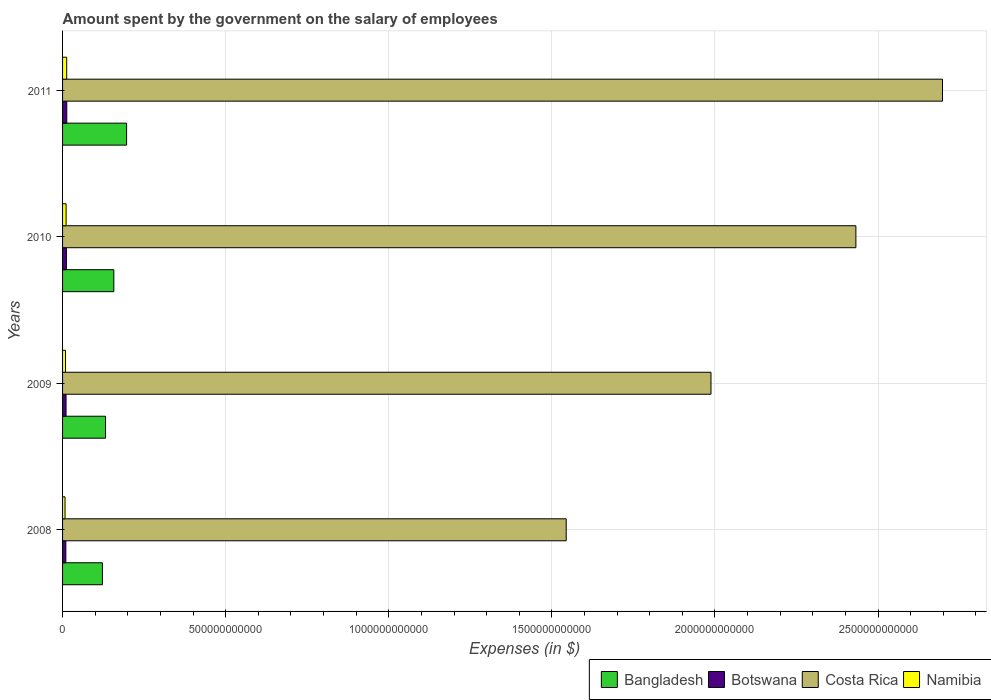How many groups of bars are there?
Your answer should be very brief. 4. In how many cases, is the number of bars for a given year not equal to the number of legend labels?
Provide a short and direct response. 0. What is the amount spent on the salary of employees by the government in Bangladesh in 2008?
Keep it short and to the point. 1.22e+11. Across all years, what is the maximum amount spent on the salary of employees by the government in Namibia?
Your answer should be very brief. 1.27e+1. Across all years, what is the minimum amount spent on the salary of employees by the government in Costa Rica?
Ensure brevity in your answer.  1.54e+12. In which year was the amount spent on the salary of employees by the government in Bangladesh maximum?
Your answer should be compact. 2011. In which year was the amount spent on the salary of employees by the government in Costa Rica minimum?
Keep it short and to the point. 2008. What is the total amount spent on the salary of employees by the government in Botswana in the graph?
Ensure brevity in your answer.  4.56e+1. What is the difference between the amount spent on the salary of employees by the government in Namibia in 2010 and that in 2011?
Your answer should be very brief. -1.89e+09. What is the difference between the amount spent on the salary of employees by the government in Botswana in 2010 and the amount spent on the salary of employees by the government in Costa Rica in 2008?
Offer a terse response. -1.53e+12. What is the average amount spent on the salary of employees by the government in Namibia per year?
Give a very brief answer. 1.00e+1. In the year 2009, what is the difference between the amount spent on the salary of employees by the government in Namibia and amount spent on the salary of employees by the government in Botswana?
Ensure brevity in your answer.  -1.64e+09. What is the ratio of the amount spent on the salary of employees by the government in Bangladesh in 2008 to that in 2011?
Keep it short and to the point. 0.62. Is the amount spent on the salary of employees by the government in Bangladesh in 2009 less than that in 2011?
Your answer should be very brief. Yes. What is the difference between the highest and the second highest amount spent on the salary of employees by the government in Namibia?
Offer a very short reply. 1.89e+09. What is the difference between the highest and the lowest amount spent on the salary of employees by the government in Namibia?
Ensure brevity in your answer.  5.13e+09. Is the sum of the amount spent on the salary of employees by the government in Bangladesh in 2008 and 2010 greater than the maximum amount spent on the salary of employees by the government in Costa Rica across all years?
Give a very brief answer. No. Is it the case that in every year, the sum of the amount spent on the salary of employees by the government in Botswana and amount spent on the salary of employees by the government in Namibia is greater than the sum of amount spent on the salary of employees by the government in Costa Rica and amount spent on the salary of employees by the government in Bangladesh?
Make the answer very short. No. What does the 1st bar from the top in 2008 represents?
Ensure brevity in your answer.  Namibia. Is it the case that in every year, the sum of the amount spent on the salary of employees by the government in Costa Rica and amount spent on the salary of employees by the government in Namibia is greater than the amount spent on the salary of employees by the government in Bangladesh?
Offer a very short reply. Yes. How many bars are there?
Give a very brief answer. 16. How many years are there in the graph?
Make the answer very short. 4. What is the difference between two consecutive major ticks on the X-axis?
Provide a succinct answer. 5.00e+11. Does the graph contain any zero values?
Offer a very short reply. No. Does the graph contain grids?
Your answer should be compact. Yes. How many legend labels are there?
Offer a terse response. 4. What is the title of the graph?
Your answer should be very brief. Amount spent by the government on the salary of employees. What is the label or title of the X-axis?
Give a very brief answer. Expenses (in $). What is the label or title of the Y-axis?
Ensure brevity in your answer.  Years. What is the Expenses (in $) of Bangladesh in 2008?
Offer a terse response. 1.22e+11. What is the Expenses (in $) in Botswana in 2008?
Offer a very short reply. 1.01e+1. What is the Expenses (in $) of Costa Rica in 2008?
Make the answer very short. 1.54e+12. What is the Expenses (in $) of Namibia in 2008?
Your answer should be very brief. 7.56e+09. What is the Expenses (in $) in Bangladesh in 2009?
Make the answer very short. 1.32e+11. What is the Expenses (in $) in Botswana in 2009?
Make the answer very short. 1.07e+1. What is the Expenses (in $) of Costa Rica in 2009?
Provide a short and direct response. 1.99e+12. What is the Expenses (in $) of Namibia in 2009?
Your answer should be very brief. 9.05e+09. What is the Expenses (in $) of Bangladesh in 2010?
Your response must be concise. 1.57e+11. What is the Expenses (in $) in Botswana in 2010?
Provide a short and direct response. 1.19e+1. What is the Expenses (in $) of Costa Rica in 2010?
Your response must be concise. 2.43e+12. What is the Expenses (in $) of Namibia in 2010?
Give a very brief answer. 1.08e+1. What is the Expenses (in $) of Bangladesh in 2011?
Give a very brief answer. 1.96e+11. What is the Expenses (in $) of Botswana in 2011?
Keep it short and to the point. 1.29e+1. What is the Expenses (in $) of Costa Rica in 2011?
Make the answer very short. 2.70e+12. What is the Expenses (in $) of Namibia in 2011?
Give a very brief answer. 1.27e+1. Across all years, what is the maximum Expenses (in $) of Bangladesh?
Ensure brevity in your answer.  1.96e+11. Across all years, what is the maximum Expenses (in $) in Botswana?
Give a very brief answer. 1.29e+1. Across all years, what is the maximum Expenses (in $) in Costa Rica?
Your answer should be compact. 2.70e+12. Across all years, what is the maximum Expenses (in $) of Namibia?
Provide a short and direct response. 1.27e+1. Across all years, what is the minimum Expenses (in $) of Bangladesh?
Give a very brief answer. 1.22e+11. Across all years, what is the minimum Expenses (in $) of Botswana?
Provide a short and direct response. 1.01e+1. Across all years, what is the minimum Expenses (in $) in Costa Rica?
Ensure brevity in your answer.  1.54e+12. Across all years, what is the minimum Expenses (in $) in Namibia?
Keep it short and to the point. 7.56e+09. What is the total Expenses (in $) of Bangladesh in the graph?
Provide a succinct answer. 6.07e+11. What is the total Expenses (in $) of Botswana in the graph?
Your answer should be very brief. 4.56e+1. What is the total Expenses (in $) of Costa Rica in the graph?
Your answer should be very brief. 8.66e+12. What is the total Expenses (in $) in Namibia in the graph?
Keep it short and to the point. 4.01e+1. What is the difference between the Expenses (in $) in Bangladesh in 2008 and that in 2009?
Make the answer very short. -9.53e+09. What is the difference between the Expenses (in $) in Botswana in 2008 and that in 2009?
Offer a very short reply. -6.17e+08. What is the difference between the Expenses (in $) in Costa Rica in 2008 and that in 2009?
Offer a very short reply. -4.44e+11. What is the difference between the Expenses (in $) of Namibia in 2008 and that in 2009?
Your response must be concise. -1.49e+09. What is the difference between the Expenses (in $) in Bangladesh in 2008 and that in 2010?
Provide a succinct answer. -3.50e+1. What is the difference between the Expenses (in $) of Botswana in 2008 and that in 2010?
Provide a short and direct response. -1.83e+09. What is the difference between the Expenses (in $) in Costa Rica in 2008 and that in 2010?
Your response must be concise. -8.88e+11. What is the difference between the Expenses (in $) of Namibia in 2008 and that in 2010?
Make the answer very short. -3.24e+09. What is the difference between the Expenses (in $) in Bangladesh in 2008 and that in 2011?
Your response must be concise. -7.41e+1. What is the difference between the Expenses (in $) of Botswana in 2008 and that in 2011?
Your answer should be very brief. -2.87e+09. What is the difference between the Expenses (in $) in Costa Rica in 2008 and that in 2011?
Make the answer very short. -1.15e+12. What is the difference between the Expenses (in $) of Namibia in 2008 and that in 2011?
Your answer should be very brief. -5.13e+09. What is the difference between the Expenses (in $) in Bangladesh in 2009 and that in 2010?
Your response must be concise. -2.55e+1. What is the difference between the Expenses (in $) in Botswana in 2009 and that in 2010?
Offer a very short reply. -1.22e+09. What is the difference between the Expenses (in $) of Costa Rica in 2009 and that in 2010?
Make the answer very short. -4.44e+11. What is the difference between the Expenses (in $) of Namibia in 2009 and that in 2010?
Provide a succinct answer. -1.76e+09. What is the difference between the Expenses (in $) in Bangladesh in 2009 and that in 2011?
Provide a succinct answer. -6.46e+1. What is the difference between the Expenses (in $) in Botswana in 2009 and that in 2011?
Keep it short and to the point. -2.26e+09. What is the difference between the Expenses (in $) in Costa Rica in 2009 and that in 2011?
Make the answer very short. -7.10e+11. What is the difference between the Expenses (in $) of Namibia in 2009 and that in 2011?
Offer a very short reply. -3.64e+09. What is the difference between the Expenses (in $) of Bangladesh in 2010 and that in 2011?
Ensure brevity in your answer.  -3.91e+1. What is the difference between the Expenses (in $) in Botswana in 2010 and that in 2011?
Your answer should be compact. -1.04e+09. What is the difference between the Expenses (in $) of Costa Rica in 2010 and that in 2011?
Your answer should be very brief. -2.65e+11. What is the difference between the Expenses (in $) in Namibia in 2010 and that in 2011?
Offer a terse response. -1.89e+09. What is the difference between the Expenses (in $) of Bangladesh in 2008 and the Expenses (in $) of Botswana in 2009?
Provide a succinct answer. 1.11e+11. What is the difference between the Expenses (in $) of Bangladesh in 2008 and the Expenses (in $) of Costa Rica in 2009?
Offer a very short reply. -1.87e+12. What is the difference between the Expenses (in $) of Bangladesh in 2008 and the Expenses (in $) of Namibia in 2009?
Your answer should be compact. 1.13e+11. What is the difference between the Expenses (in $) in Botswana in 2008 and the Expenses (in $) in Costa Rica in 2009?
Your response must be concise. -1.98e+12. What is the difference between the Expenses (in $) in Botswana in 2008 and the Expenses (in $) in Namibia in 2009?
Your answer should be compact. 1.02e+09. What is the difference between the Expenses (in $) of Costa Rica in 2008 and the Expenses (in $) of Namibia in 2009?
Offer a very short reply. 1.53e+12. What is the difference between the Expenses (in $) in Bangladesh in 2008 and the Expenses (in $) in Botswana in 2010?
Ensure brevity in your answer.  1.10e+11. What is the difference between the Expenses (in $) of Bangladesh in 2008 and the Expenses (in $) of Costa Rica in 2010?
Your answer should be very brief. -2.31e+12. What is the difference between the Expenses (in $) of Bangladesh in 2008 and the Expenses (in $) of Namibia in 2010?
Keep it short and to the point. 1.11e+11. What is the difference between the Expenses (in $) in Botswana in 2008 and the Expenses (in $) in Costa Rica in 2010?
Ensure brevity in your answer.  -2.42e+12. What is the difference between the Expenses (in $) of Botswana in 2008 and the Expenses (in $) of Namibia in 2010?
Keep it short and to the point. -7.35e+08. What is the difference between the Expenses (in $) in Costa Rica in 2008 and the Expenses (in $) in Namibia in 2010?
Your response must be concise. 1.53e+12. What is the difference between the Expenses (in $) in Bangladesh in 2008 and the Expenses (in $) in Botswana in 2011?
Give a very brief answer. 1.09e+11. What is the difference between the Expenses (in $) of Bangladesh in 2008 and the Expenses (in $) of Costa Rica in 2011?
Offer a terse response. -2.58e+12. What is the difference between the Expenses (in $) of Bangladesh in 2008 and the Expenses (in $) of Namibia in 2011?
Your answer should be compact. 1.09e+11. What is the difference between the Expenses (in $) in Botswana in 2008 and the Expenses (in $) in Costa Rica in 2011?
Offer a terse response. -2.69e+12. What is the difference between the Expenses (in $) of Botswana in 2008 and the Expenses (in $) of Namibia in 2011?
Make the answer very short. -2.62e+09. What is the difference between the Expenses (in $) of Costa Rica in 2008 and the Expenses (in $) of Namibia in 2011?
Your answer should be very brief. 1.53e+12. What is the difference between the Expenses (in $) in Bangladesh in 2009 and the Expenses (in $) in Botswana in 2010?
Give a very brief answer. 1.20e+11. What is the difference between the Expenses (in $) in Bangladesh in 2009 and the Expenses (in $) in Costa Rica in 2010?
Your answer should be compact. -2.30e+12. What is the difference between the Expenses (in $) in Bangladesh in 2009 and the Expenses (in $) in Namibia in 2010?
Provide a succinct answer. 1.21e+11. What is the difference between the Expenses (in $) in Botswana in 2009 and the Expenses (in $) in Costa Rica in 2010?
Your answer should be compact. -2.42e+12. What is the difference between the Expenses (in $) of Botswana in 2009 and the Expenses (in $) of Namibia in 2010?
Your answer should be very brief. -1.19e+08. What is the difference between the Expenses (in $) of Costa Rica in 2009 and the Expenses (in $) of Namibia in 2010?
Your answer should be very brief. 1.98e+12. What is the difference between the Expenses (in $) of Bangladesh in 2009 and the Expenses (in $) of Botswana in 2011?
Keep it short and to the point. 1.19e+11. What is the difference between the Expenses (in $) of Bangladesh in 2009 and the Expenses (in $) of Costa Rica in 2011?
Make the answer very short. -2.57e+12. What is the difference between the Expenses (in $) in Bangladesh in 2009 and the Expenses (in $) in Namibia in 2011?
Offer a terse response. 1.19e+11. What is the difference between the Expenses (in $) of Botswana in 2009 and the Expenses (in $) of Costa Rica in 2011?
Provide a succinct answer. -2.69e+12. What is the difference between the Expenses (in $) of Botswana in 2009 and the Expenses (in $) of Namibia in 2011?
Ensure brevity in your answer.  -2.01e+09. What is the difference between the Expenses (in $) of Costa Rica in 2009 and the Expenses (in $) of Namibia in 2011?
Make the answer very short. 1.98e+12. What is the difference between the Expenses (in $) in Bangladesh in 2010 and the Expenses (in $) in Botswana in 2011?
Provide a short and direct response. 1.44e+11. What is the difference between the Expenses (in $) of Bangladesh in 2010 and the Expenses (in $) of Costa Rica in 2011?
Your response must be concise. -2.54e+12. What is the difference between the Expenses (in $) in Bangladesh in 2010 and the Expenses (in $) in Namibia in 2011?
Offer a very short reply. 1.44e+11. What is the difference between the Expenses (in $) of Botswana in 2010 and the Expenses (in $) of Costa Rica in 2011?
Your answer should be very brief. -2.69e+12. What is the difference between the Expenses (in $) of Botswana in 2010 and the Expenses (in $) of Namibia in 2011?
Keep it short and to the point. -7.91e+08. What is the difference between the Expenses (in $) in Costa Rica in 2010 and the Expenses (in $) in Namibia in 2011?
Your response must be concise. 2.42e+12. What is the average Expenses (in $) in Bangladesh per year?
Your response must be concise. 1.52e+11. What is the average Expenses (in $) of Botswana per year?
Give a very brief answer. 1.14e+1. What is the average Expenses (in $) of Costa Rica per year?
Ensure brevity in your answer.  2.17e+12. What is the average Expenses (in $) in Namibia per year?
Give a very brief answer. 1.00e+1. In the year 2008, what is the difference between the Expenses (in $) of Bangladesh and Expenses (in $) of Botswana?
Offer a very short reply. 1.12e+11. In the year 2008, what is the difference between the Expenses (in $) of Bangladesh and Expenses (in $) of Costa Rica?
Ensure brevity in your answer.  -1.42e+12. In the year 2008, what is the difference between the Expenses (in $) of Bangladesh and Expenses (in $) of Namibia?
Offer a terse response. 1.15e+11. In the year 2008, what is the difference between the Expenses (in $) of Botswana and Expenses (in $) of Costa Rica?
Ensure brevity in your answer.  -1.53e+12. In the year 2008, what is the difference between the Expenses (in $) of Botswana and Expenses (in $) of Namibia?
Your answer should be compact. 2.51e+09. In the year 2008, what is the difference between the Expenses (in $) of Costa Rica and Expenses (in $) of Namibia?
Provide a succinct answer. 1.54e+12. In the year 2009, what is the difference between the Expenses (in $) of Bangladesh and Expenses (in $) of Botswana?
Offer a very short reply. 1.21e+11. In the year 2009, what is the difference between the Expenses (in $) in Bangladesh and Expenses (in $) in Costa Rica?
Provide a succinct answer. -1.86e+12. In the year 2009, what is the difference between the Expenses (in $) in Bangladesh and Expenses (in $) in Namibia?
Your answer should be compact. 1.23e+11. In the year 2009, what is the difference between the Expenses (in $) in Botswana and Expenses (in $) in Costa Rica?
Give a very brief answer. -1.98e+12. In the year 2009, what is the difference between the Expenses (in $) in Botswana and Expenses (in $) in Namibia?
Provide a succinct answer. 1.64e+09. In the year 2009, what is the difference between the Expenses (in $) in Costa Rica and Expenses (in $) in Namibia?
Make the answer very short. 1.98e+12. In the year 2010, what is the difference between the Expenses (in $) in Bangladesh and Expenses (in $) in Botswana?
Offer a terse response. 1.45e+11. In the year 2010, what is the difference between the Expenses (in $) of Bangladesh and Expenses (in $) of Costa Rica?
Ensure brevity in your answer.  -2.27e+12. In the year 2010, what is the difference between the Expenses (in $) in Bangladesh and Expenses (in $) in Namibia?
Keep it short and to the point. 1.46e+11. In the year 2010, what is the difference between the Expenses (in $) of Botswana and Expenses (in $) of Costa Rica?
Ensure brevity in your answer.  -2.42e+12. In the year 2010, what is the difference between the Expenses (in $) of Botswana and Expenses (in $) of Namibia?
Provide a short and direct response. 1.10e+09. In the year 2010, what is the difference between the Expenses (in $) in Costa Rica and Expenses (in $) in Namibia?
Make the answer very short. 2.42e+12. In the year 2011, what is the difference between the Expenses (in $) in Bangladesh and Expenses (in $) in Botswana?
Give a very brief answer. 1.83e+11. In the year 2011, what is the difference between the Expenses (in $) of Bangladesh and Expenses (in $) of Costa Rica?
Provide a short and direct response. -2.50e+12. In the year 2011, what is the difference between the Expenses (in $) of Bangladesh and Expenses (in $) of Namibia?
Your answer should be very brief. 1.84e+11. In the year 2011, what is the difference between the Expenses (in $) in Botswana and Expenses (in $) in Costa Rica?
Your answer should be compact. -2.68e+12. In the year 2011, what is the difference between the Expenses (in $) in Botswana and Expenses (in $) in Namibia?
Your answer should be compact. 2.51e+08. In the year 2011, what is the difference between the Expenses (in $) in Costa Rica and Expenses (in $) in Namibia?
Keep it short and to the point. 2.68e+12. What is the ratio of the Expenses (in $) in Bangladesh in 2008 to that in 2009?
Your response must be concise. 0.93. What is the ratio of the Expenses (in $) in Botswana in 2008 to that in 2009?
Provide a short and direct response. 0.94. What is the ratio of the Expenses (in $) in Costa Rica in 2008 to that in 2009?
Keep it short and to the point. 0.78. What is the ratio of the Expenses (in $) of Namibia in 2008 to that in 2009?
Keep it short and to the point. 0.84. What is the ratio of the Expenses (in $) of Bangladesh in 2008 to that in 2010?
Offer a very short reply. 0.78. What is the ratio of the Expenses (in $) in Botswana in 2008 to that in 2010?
Keep it short and to the point. 0.85. What is the ratio of the Expenses (in $) of Costa Rica in 2008 to that in 2010?
Your answer should be very brief. 0.63. What is the ratio of the Expenses (in $) in Namibia in 2008 to that in 2010?
Offer a very short reply. 0.7. What is the ratio of the Expenses (in $) of Bangladesh in 2008 to that in 2011?
Make the answer very short. 0.62. What is the ratio of the Expenses (in $) in Botswana in 2008 to that in 2011?
Offer a terse response. 0.78. What is the ratio of the Expenses (in $) in Costa Rica in 2008 to that in 2011?
Offer a very short reply. 0.57. What is the ratio of the Expenses (in $) of Namibia in 2008 to that in 2011?
Keep it short and to the point. 0.6. What is the ratio of the Expenses (in $) of Bangladesh in 2009 to that in 2010?
Offer a terse response. 0.84. What is the ratio of the Expenses (in $) of Botswana in 2009 to that in 2010?
Provide a short and direct response. 0.9. What is the ratio of the Expenses (in $) of Costa Rica in 2009 to that in 2010?
Provide a succinct answer. 0.82. What is the ratio of the Expenses (in $) in Namibia in 2009 to that in 2010?
Provide a succinct answer. 0.84. What is the ratio of the Expenses (in $) of Bangladesh in 2009 to that in 2011?
Make the answer very short. 0.67. What is the ratio of the Expenses (in $) in Botswana in 2009 to that in 2011?
Provide a succinct answer. 0.83. What is the ratio of the Expenses (in $) in Costa Rica in 2009 to that in 2011?
Ensure brevity in your answer.  0.74. What is the ratio of the Expenses (in $) in Namibia in 2009 to that in 2011?
Provide a succinct answer. 0.71. What is the ratio of the Expenses (in $) in Bangladesh in 2010 to that in 2011?
Provide a succinct answer. 0.8. What is the ratio of the Expenses (in $) of Botswana in 2010 to that in 2011?
Provide a succinct answer. 0.92. What is the ratio of the Expenses (in $) of Costa Rica in 2010 to that in 2011?
Keep it short and to the point. 0.9. What is the ratio of the Expenses (in $) in Namibia in 2010 to that in 2011?
Ensure brevity in your answer.  0.85. What is the difference between the highest and the second highest Expenses (in $) in Bangladesh?
Keep it short and to the point. 3.91e+1. What is the difference between the highest and the second highest Expenses (in $) in Botswana?
Make the answer very short. 1.04e+09. What is the difference between the highest and the second highest Expenses (in $) of Costa Rica?
Your response must be concise. 2.65e+11. What is the difference between the highest and the second highest Expenses (in $) in Namibia?
Provide a short and direct response. 1.89e+09. What is the difference between the highest and the lowest Expenses (in $) of Bangladesh?
Provide a succinct answer. 7.41e+1. What is the difference between the highest and the lowest Expenses (in $) in Botswana?
Ensure brevity in your answer.  2.87e+09. What is the difference between the highest and the lowest Expenses (in $) of Costa Rica?
Keep it short and to the point. 1.15e+12. What is the difference between the highest and the lowest Expenses (in $) in Namibia?
Your answer should be compact. 5.13e+09. 